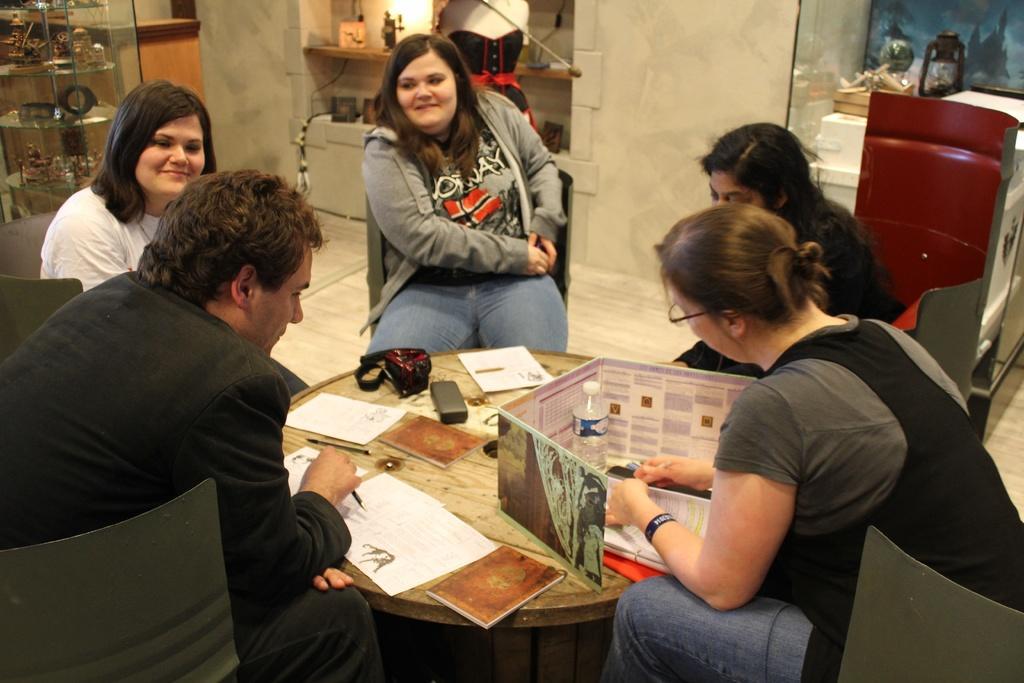Could you give a brief overview of what you see in this image? This picture shows group of people seated on the chairs and we see few papers and a bottle on the table 